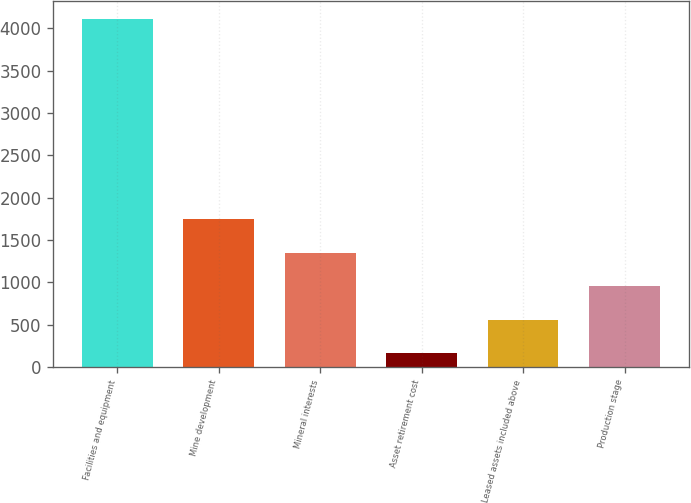Convert chart to OTSL. <chart><loc_0><loc_0><loc_500><loc_500><bar_chart><fcel>Facilities and equipment<fcel>Mine development<fcel>Mineral interests<fcel>Asset retirement cost<fcel>Leased assets included above<fcel>Production stage<nl><fcel>4110<fcel>1743<fcel>1348.5<fcel>165<fcel>559.5<fcel>954<nl></chart> 